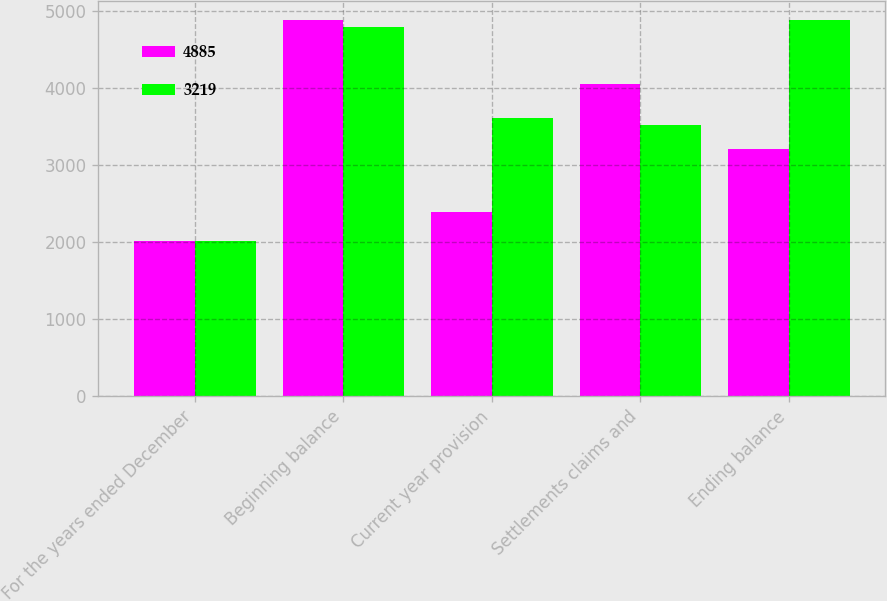<chart> <loc_0><loc_0><loc_500><loc_500><stacked_bar_chart><ecel><fcel>For the years ended December<fcel>Beginning balance<fcel>Current year provision<fcel>Settlements claims and<fcel>Ending balance<nl><fcel>4885<fcel>2018<fcel>4885<fcel>2392<fcel>4058<fcel>3219<nl><fcel>3219<fcel>2017<fcel>4800<fcel>3611<fcel>3526<fcel>4885<nl></chart> 